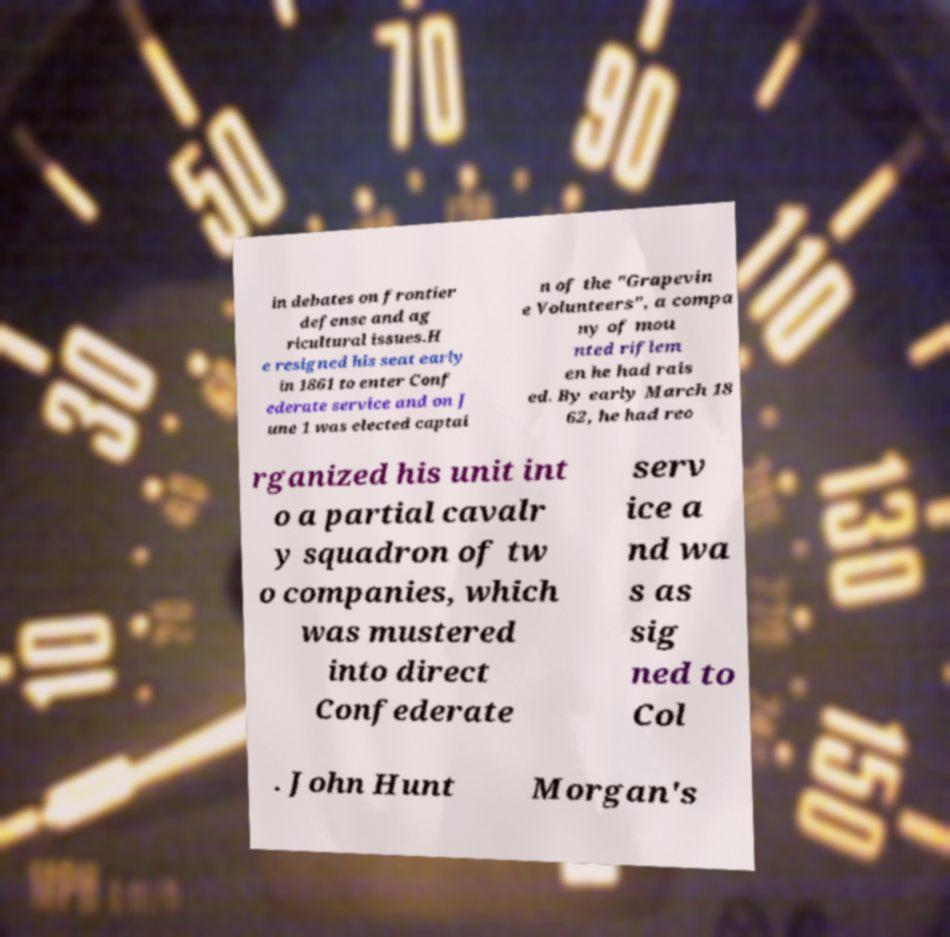Could you extract and type out the text from this image? in debates on frontier defense and ag ricultural issues.H e resigned his seat early in 1861 to enter Conf ederate service and on J une 1 was elected captai n of the "Grapevin e Volunteers", a compa ny of mou nted riflem en he had rais ed. By early March 18 62, he had reo rganized his unit int o a partial cavalr y squadron of tw o companies, which was mustered into direct Confederate serv ice a nd wa s as sig ned to Col . John Hunt Morgan's 